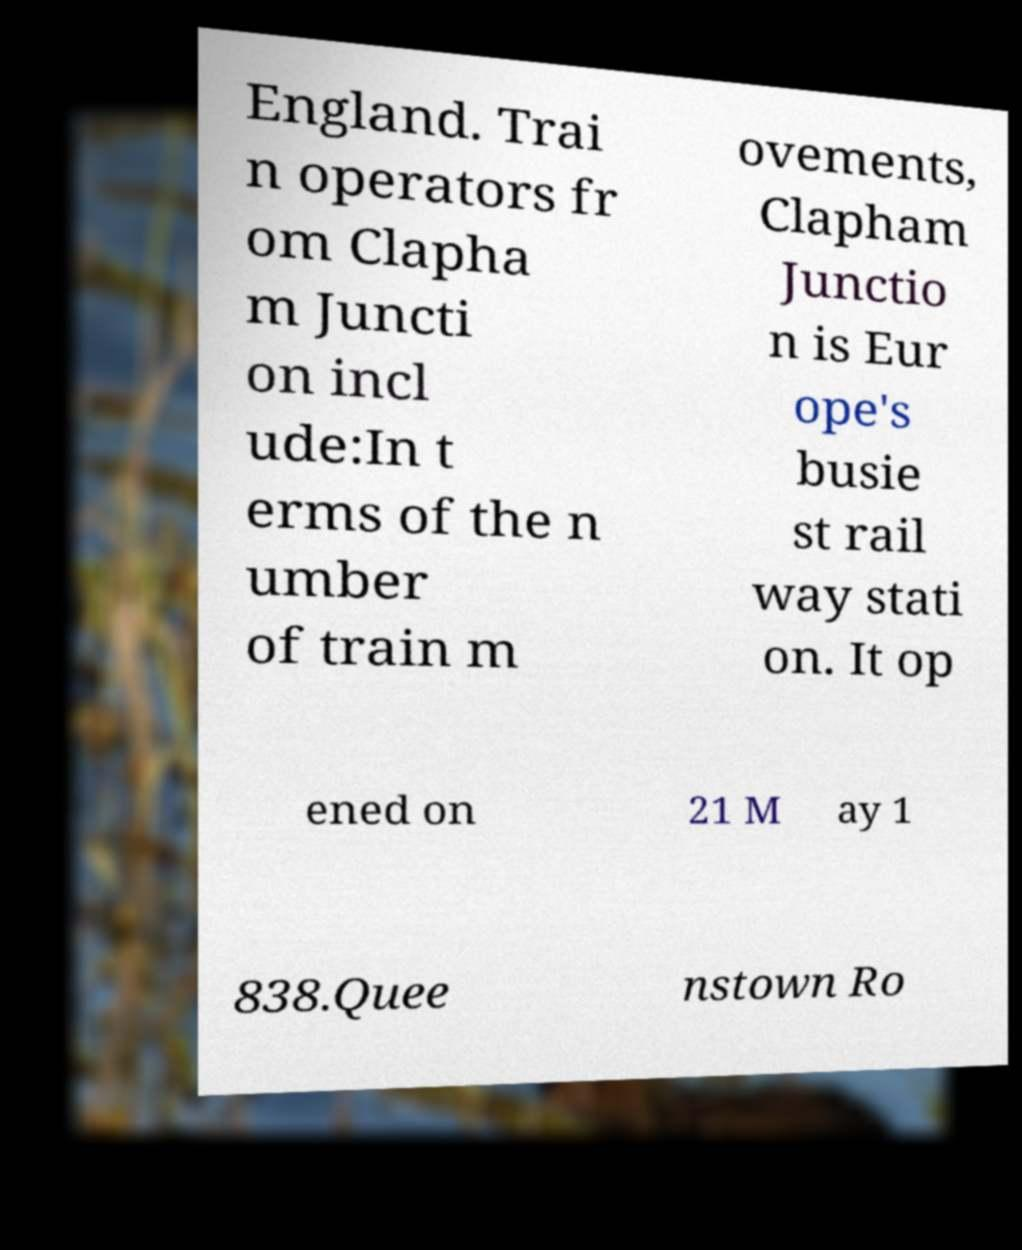Could you assist in decoding the text presented in this image and type it out clearly? England. Trai n operators fr om Clapha m Juncti on incl ude:In t erms of the n umber of train m ovements, Clapham Junctio n is Eur ope's busie st rail way stati on. It op ened on 21 M ay 1 838.Quee nstown Ro 